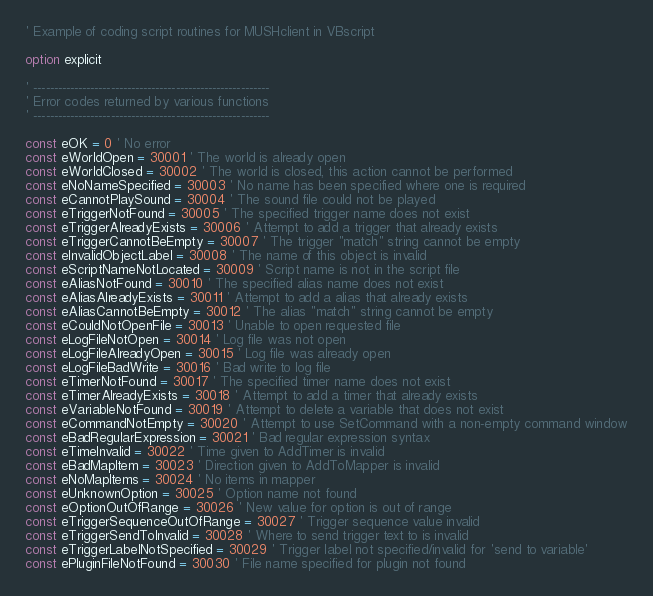Convert code to text. <code><loc_0><loc_0><loc_500><loc_500><_VisualBasic_>' Example of coding script routines for MUSHclient in VBscript

option explicit

' ----------------------------------------------------------
' Error codes returned by various functions
' ----------------------------------------------------------

const eOK = 0 ' No error
const eWorldOpen = 30001 ' The world is already open
const eWorldClosed = 30002 ' The world is closed, this action cannot be performed
const eNoNameSpecified = 30003 ' No name has been specified where one is required
const eCannotPlaySound = 30004 ' The sound file could not be played
const eTriggerNotFound = 30005 ' The specified trigger name does not exist
const eTriggerAlreadyExists = 30006 ' Attempt to add a trigger that already exists
const eTriggerCannotBeEmpty = 30007 ' The trigger "match" string cannot be empty
const eInvalidObjectLabel = 30008 ' The name of this object is invalid
const eScriptNameNotLocated = 30009 ' Script name is not in the script file
const eAliasNotFound = 30010 ' The specified alias name does not exist
const eAliasAlreadyExists = 30011 ' Attempt to add a alias that already exists
const eAliasCannotBeEmpty = 30012 ' The alias "match" string cannot be empty
const eCouldNotOpenFile = 30013 ' Unable to open requested file
const eLogFileNotOpen = 30014 ' Log file was not open
const eLogFileAlreadyOpen = 30015 ' Log file was already open
const eLogFileBadWrite = 30016 ' Bad write to log file
const eTimerNotFound = 30017 ' The specified timer name does not exist
const eTimerAlreadyExists = 30018 ' Attempt to add a timer that already exists
const eVariableNotFound = 30019 ' Attempt to delete a variable that does not exist
const eCommandNotEmpty = 30020 ' Attempt to use SetCommand with a non-empty command window
const eBadRegularExpression = 30021 ' Bad regular expression syntax
const eTimeInvalid = 30022 ' Time given to AddTimer is invalid
const eBadMapItem = 30023 ' Direction given to AddToMapper is invalid
const eNoMapItems = 30024 ' No items in mapper
const eUnknownOption = 30025 ' Option name not found
const eOptionOutOfRange = 30026 ' New value for option is out of range
const eTriggerSequenceOutOfRange = 30027 ' Trigger sequence value invalid
const eTriggerSendToInvalid = 30028 ' Where to send trigger text to is invalid
const eTriggerLabelNotSpecified = 30029 ' Trigger label not specified/invalid for 'send to variable'
const ePluginFileNotFound = 30030 ' File name specified for plugin not found</code> 